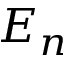Convert formula to latex. <formula><loc_0><loc_0><loc_500><loc_500>E _ { n }</formula> 